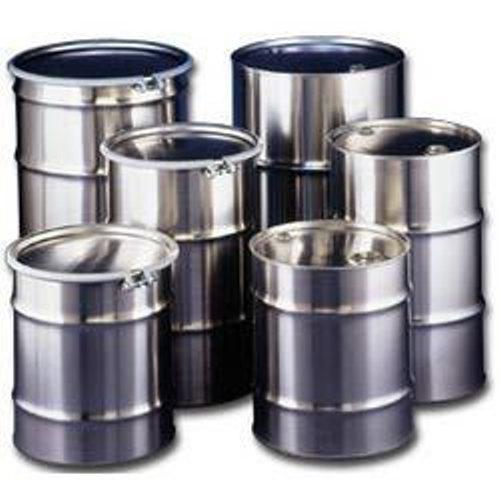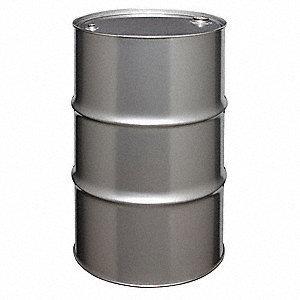The first image is the image on the left, the second image is the image on the right. Analyze the images presented: Is the assertion "All barrels shown are the same color, but one image contains a single barrel, while the other contains at least five." valid? Answer yes or no. Yes. The first image is the image on the left, the second image is the image on the right. Assess this claim about the two images: "There are at least four cans.". Correct or not? Answer yes or no. Yes. 